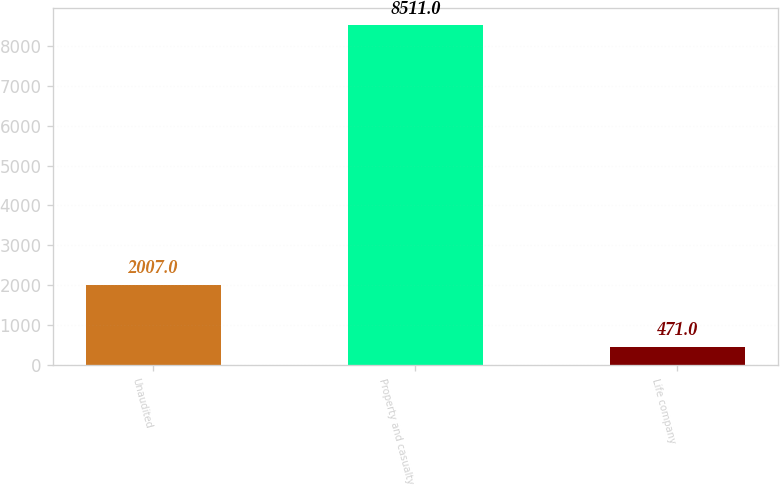Convert chart. <chart><loc_0><loc_0><loc_500><loc_500><bar_chart><fcel>Unaudited<fcel>Property and casualty<fcel>Life company<nl><fcel>2007<fcel>8511<fcel>471<nl></chart> 